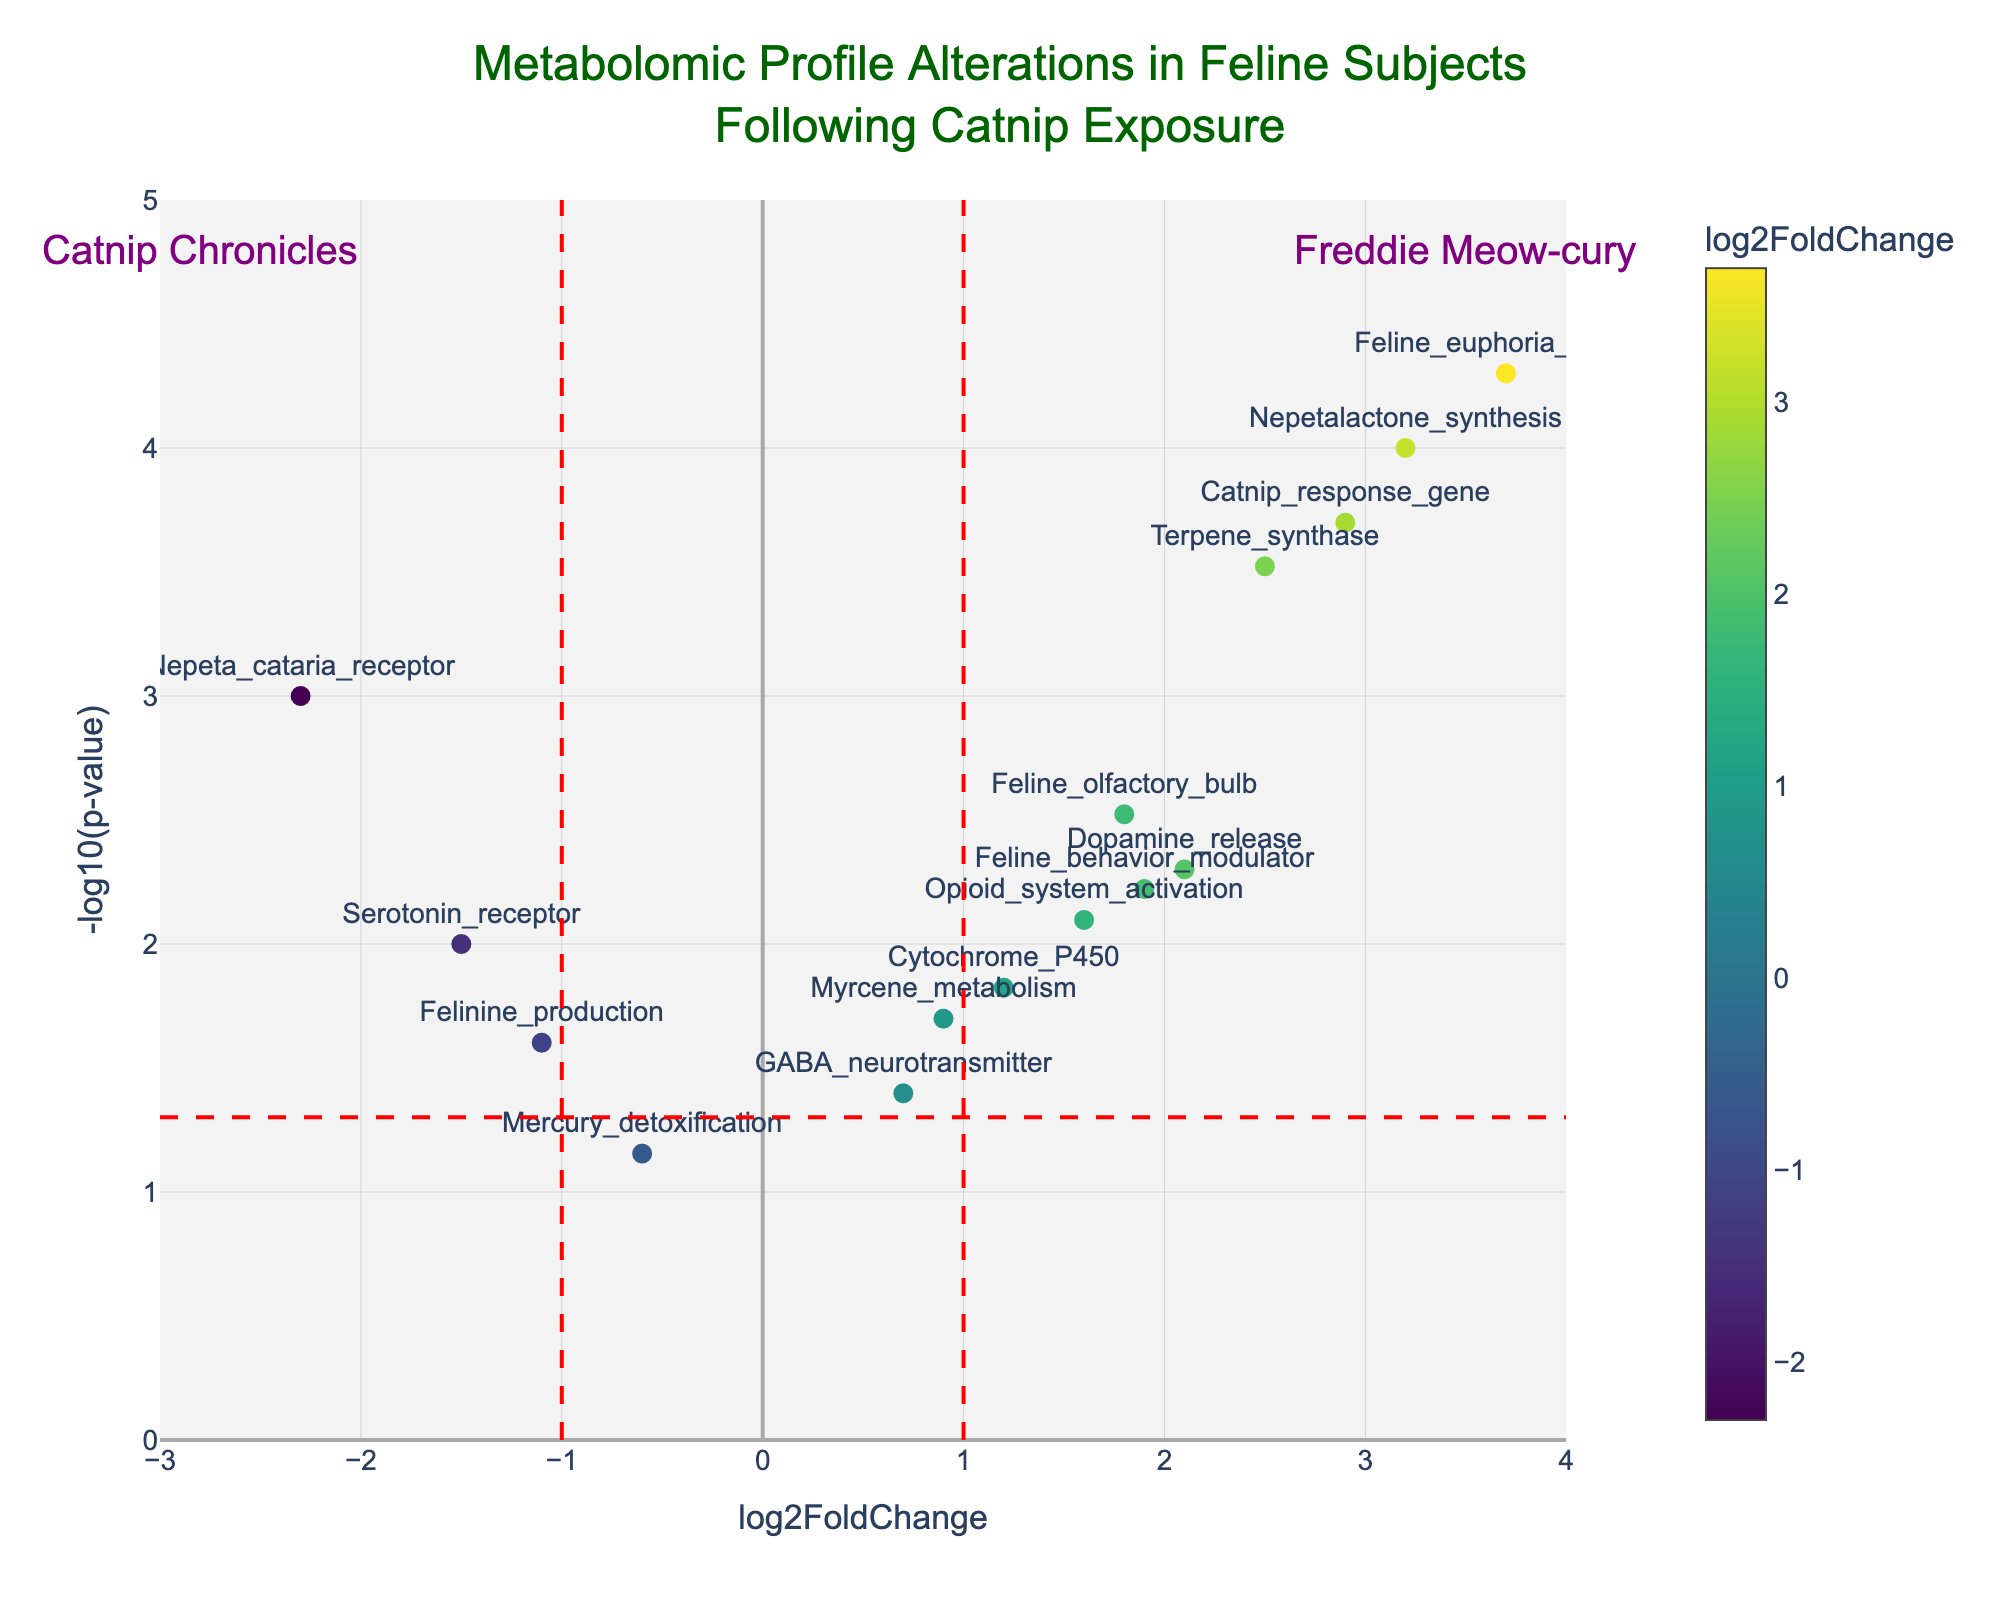What is the title of the plot? The title of the plot can be found at the top of the figure, which usually summarizes the main topic the plot addresses.
Answer: Metabolomic Profile Alterations in Feline Subjects Following Catnip Exposure Which gene has the highest log2FoldChange? By examining the x-axis, which represents log2FoldChange, the gene farthest to the right has the highest change.
Answer: Feline_euphoria_marker What gene is associated with the lowest p-value? The y-axis represents -log10(p-value), so the gene with the highest value on this axis has the lowest p-value.
Answer: Feline_euphoria_marker How many genes have a log2FoldChange greater than 1? Identify the data points to the right of the vertical line at x = 1.
Answer: 7 Which genes fall above the significance threshold given by -log10(0.05)? The significance threshold is shown as a horizontal line, so any data points above this line meet the threshold.
Answer: Nepeta_cataria_receptor, Feline_olfactory_bulb, Nepetalactone_synthesis, Dopamine_release, Serotonin_receptor, Opioid_system_activation, Cytochrome_P450, Terpene_synthase, Feline_euphoria_marker, Catnip_response_gene, Feline_behavior_modulator How does the log2FoldChange of Catnip_response_gene compare to Cytochrome_P450? Compare their positions along the x-axis for log2FoldChange. Catnip_response_gene is farther to the right.
Answer: Catnip_response_gene has a higher log2FoldChange than Cytochrome_P450 What's the color scale in the plot representing? Investigate the color bar legend alongside the plot to understand what it denotes.
Answer: log2FoldChange Which data point has the smallest -log10(p-value) and what does this mean for its p-value? The data point closest to the x-axis has the smallest -log10(p-value), indicating it has the highest p-value in this plot.
Answer: Mercury_detoxification has the smallest -log10(p-value) which means it has the highest p-value What genes involve in the significant negative fold change? Look for genes to the left of the vertical line at x = -1 and above the horizontal significance line.
Answer: Nepeta_cataria_receptor, Serotonin_receptor Which gene has both substantial change (high absolute log2FoldChange) and high statistical significance (low p-value)? Search for the data points farthest from the origin in both axes, top right or bottom left.
Answer: Feline_euphoria_marker 